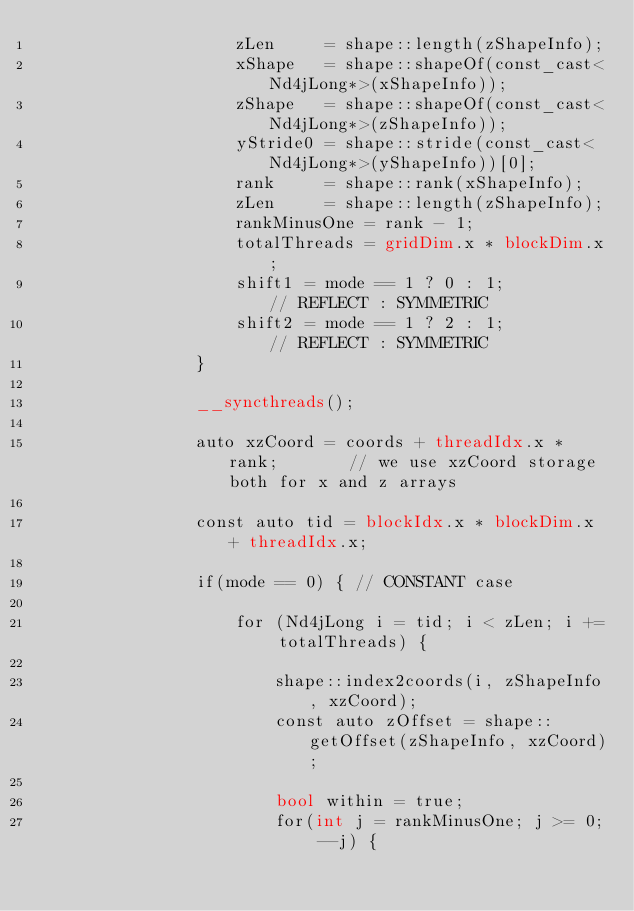<code> <loc_0><loc_0><loc_500><loc_500><_Cuda_>                    zLen     = shape::length(zShapeInfo);
                    xShape   = shape::shapeOf(const_cast<Nd4jLong*>(xShapeInfo));
                    zShape   = shape::shapeOf(const_cast<Nd4jLong*>(zShapeInfo));
                    yStride0 = shape::stride(const_cast<Nd4jLong*>(yShapeInfo))[0];
                    rank     = shape::rank(xShapeInfo);
                    zLen     = shape::length(zShapeInfo);
                    rankMinusOne = rank - 1;
                    totalThreads = gridDim.x * blockDim.x;
                    shift1 = mode == 1 ? 0 : 1;         // REFLECT : SYMMETRIC
                    shift2 = mode == 1 ? 2 : 1;         // REFLECT : SYMMETRIC
                }

                __syncthreads();

                auto xzCoord = coords + threadIdx.x * rank;       // we use xzCoord storage both for x and z arrays

                const auto tid = blockIdx.x * blockDim.x + threadIdx.x;

                if(mode == 0) { // CONSTANT case

                    for (Nd4jLong i = tid; i < zLen; i += totalThreads) {

                        shape::index2coords(i, zShapeInfo, xzCoord);
                        const auto zOffset = shape::getOffset(zShapeInfo, xzCoord);

                        bool within = true;
                        for(int j = rankMinusOne; j >= 0; --j) {</code> 